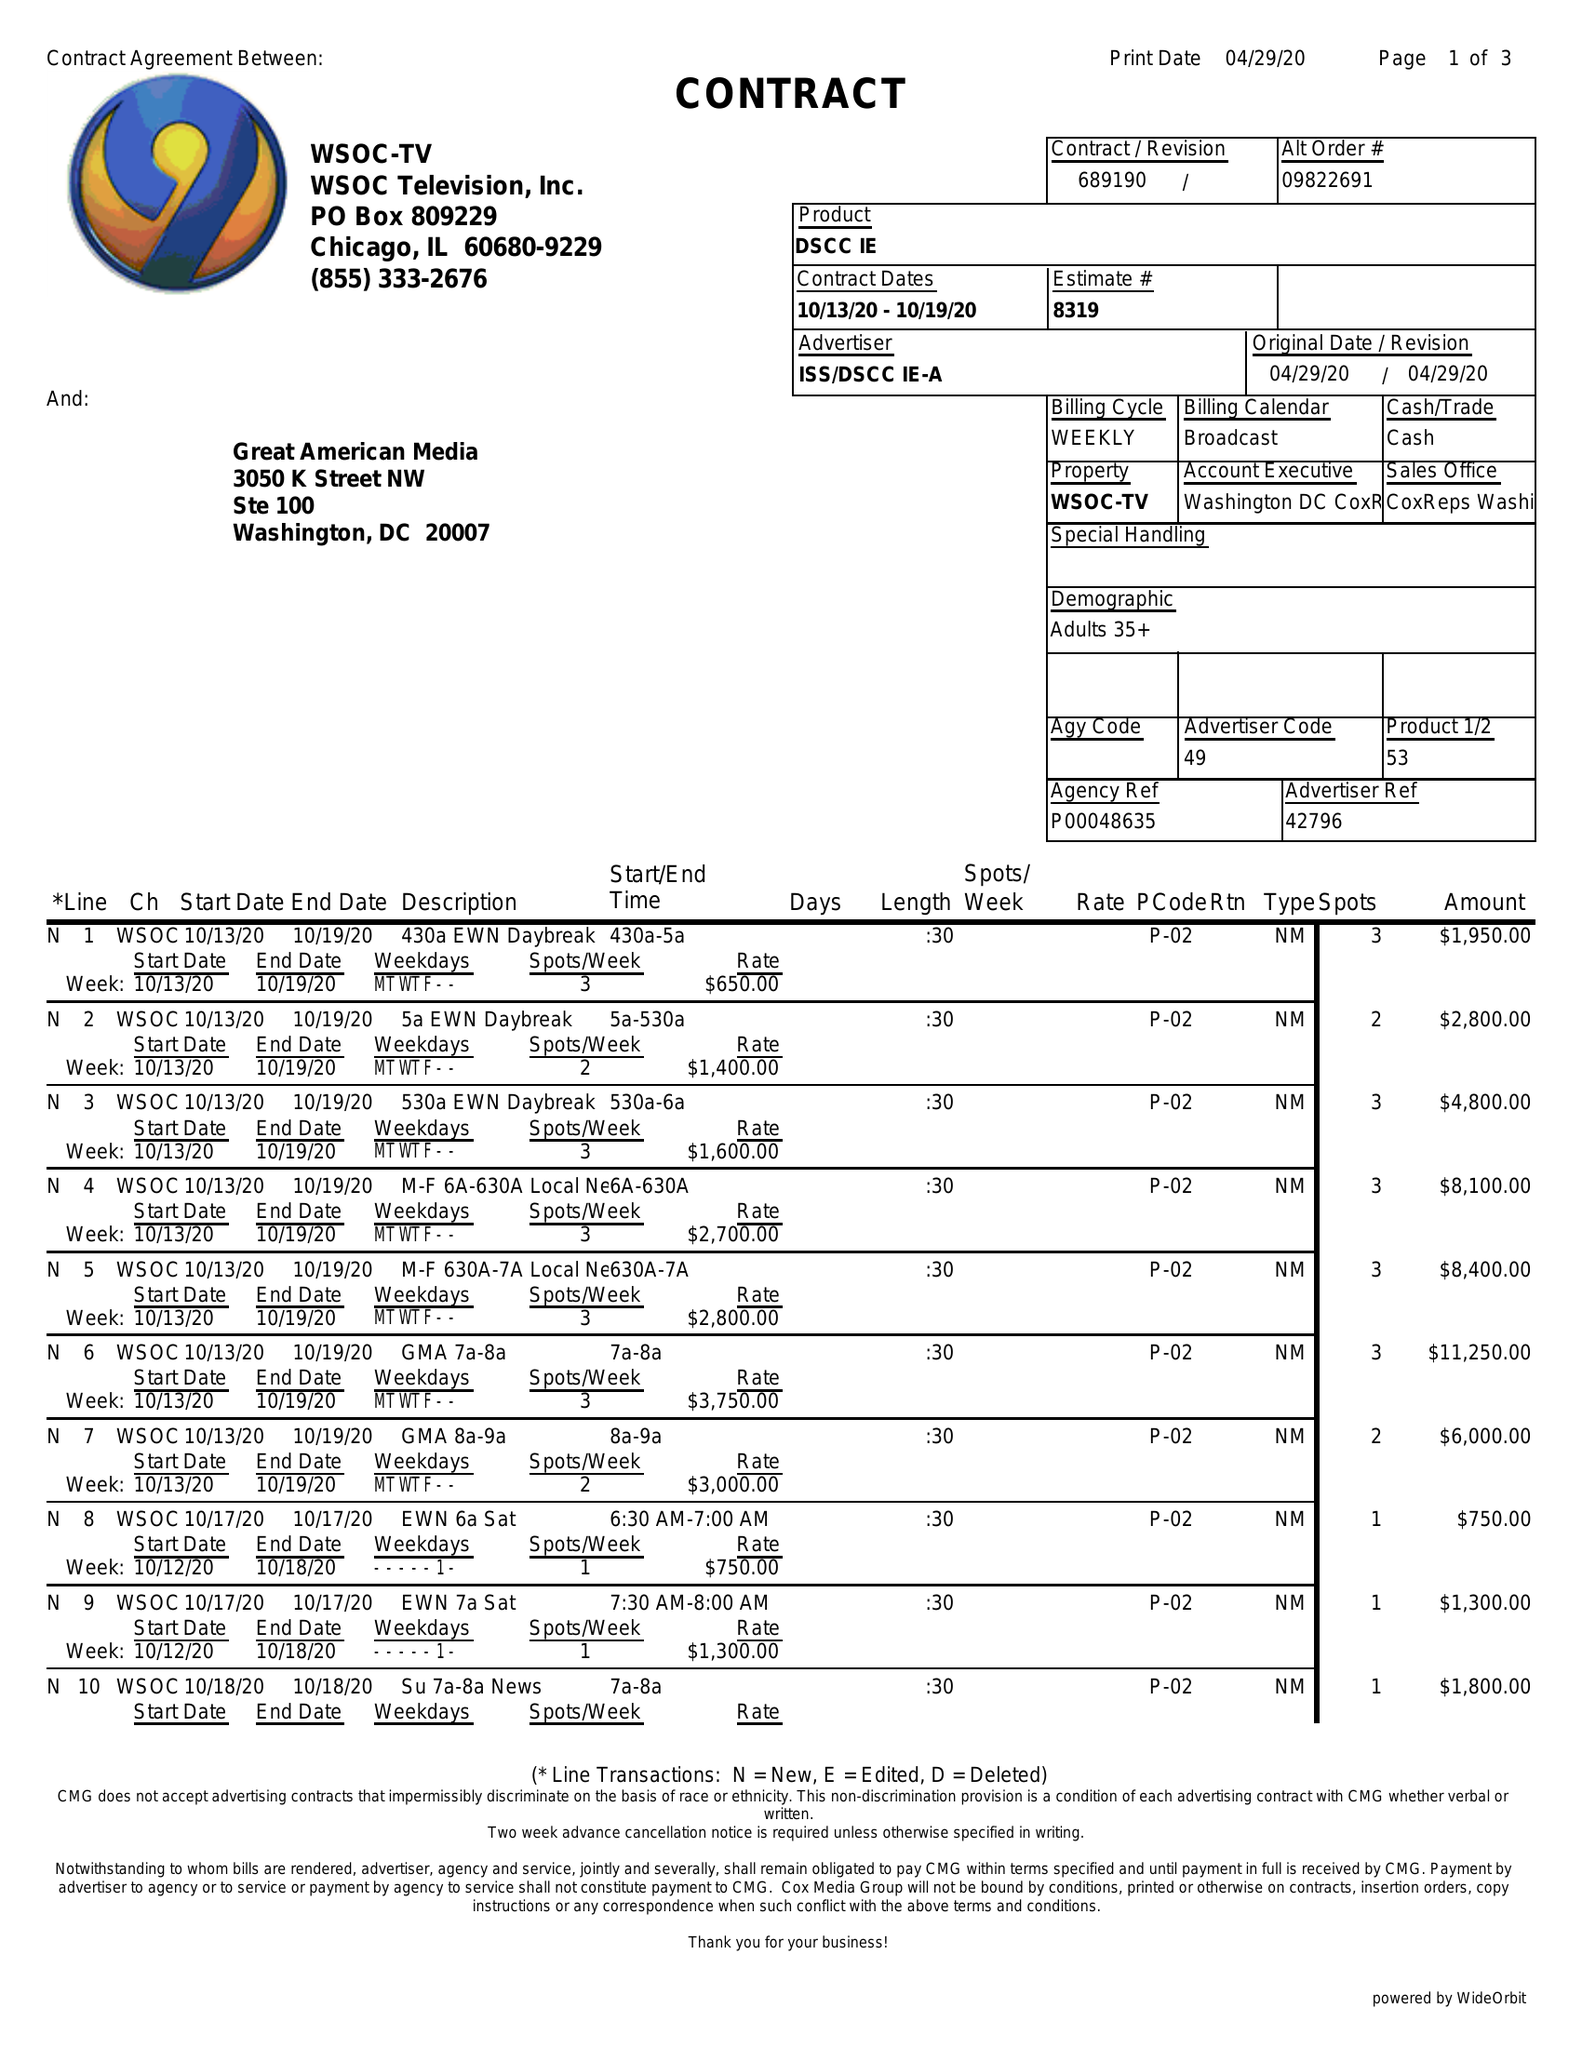What is the value for the advertiser?
Answer the question using a single word or phrase. ISS/DSCCIE-A 